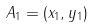<formula> <loc_0><loc_0><loc_500><loc_500>A _ { 1 } = ( x _ { 1 } , y _ { 1 } )</formula> 